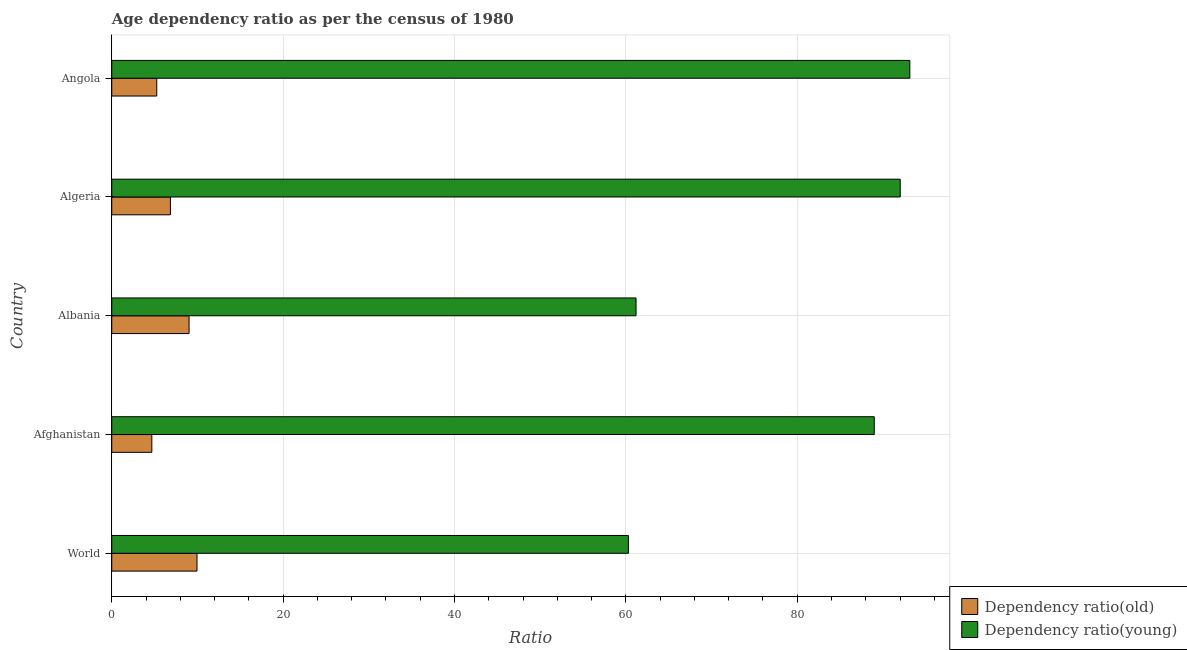How many different coloured bars are there?
Your response must be concise. 2. How many groups of bars are there?
Make the answer very short. 5. Are the number of bars per tick equal to the number of legend labels?
Your answer should be very brief. Yes. How many bars are there on the 1st tick from the top?
Provide a succinct answer. 2. What is the label of the 4th group of bars from the top?
Offer a very short reply. Afghanistan. In how many cases, is the number of bars for a given country not equal to the number of legend labels?
Offer a terse response. 0. What is the age dependency ratio(old) in Afghanistan?
Your answer should be very brief. 4.68. Across all countries, what is the maximum age dependency ratio(young)?
Make the answer very short. 93.14. Across all countries, what is the minimum age dependency ratio(young)?
Make the answer very short. 60.3. In which country was the age dependency ratio(old) maximum?
Give a very brief answer. World. In which country was the age dependency ratio(old) minimum?
Offer a terse response. Afghanistan. What is the total age dependency ratio(old) in the graph?
Give a very brief answer. 35.75. What is the difference between the age dependency ratio(old) in Algeria and that in Angola?
Make the answer very short. 1.59. What is the difference between the age dependency ratio(old) in Angola and the age dependency ratio(young) in Albania?
Offer a very short reply. -55.93. What is the average age dependency ratio(young) per country?
Keep it short and to the point. 79.13. What is the difference between the age dependency ratio(old) and age dependency ratio(young) in Afghanistan?
Ensure brevity in your answer.  -84.31. What is the ratio of the age dependency ratio(young) in Albania to that in Angola?
Make the answer very short. 0.66. What is the difference between the highest and the second highest age dependency ratio(young)?
Provide a succinct answer. 1.12. What is the difference between the highest and the lowest age dependency ratio(young)?
Ensure brevity in your answer.  32.84. In how many countries, is the age dependency ratio(old) greater than the average age dependency ratio(old) taken over all countries?
Make the answer very short. 2. What does the 1st bar from the top in Afghanistan represents?
Ensure brevity in your answer.  Dependency ratio(young). What does the 1st bar from the bottom in World represents?
Keep it short and to the point. Dependency ratio(old). How many bars are there?
Offer a very short reply. 10. Are all the bars in the graph horizontal?
Offer a terse response. Yes. How many countries are there in the graph?
Your answer should be compact. 5. What is the difference between two consecutive major ticks on the X-axis?
Your answer should be very brief. 20. Are the values on the major ticks of X-axis written in scientific E-notation?
Offer a terse response. No. Does the graph contain grids?
Provide a succinct answer. Yes. Where does the legend appear in the graph?
Your answer should be compact. Bottom right. How many legend labels are there?
Provide a short and direct response. 2. What is the title of the graph?
Give a very brief answer. Age dependency ratio as per the census of 1980. Does "Drinking water services" appear as one of the legend labels in the graph?
Provide a short and direct response. No. What is the label or title of the X-axis?
Your response must be concise. Ratio. What is the label or title of the Y-axis?
Your answer should be compact. Country. What is the Ratio of Dependency ratio(old) in World?
Offer a terse response. 9.95. What is the Ratio in Dependency ratio(young) in World?
Give a very brief answer. 60.3. What is the Ratio in Dependency ratio(old) in Afghanistan?
Ensure brevity in your answer.  4.68. What is the Ratio of Dependency ratio(young) in Afghanistan?
Your answer should be compact. 88.99. What is the Ratio in Dependency ratio(old) in Albania?
Provide a succinct answer. 9.02. What is the Ratio in Dependency ratio(young) in Albania?
Give a very brief answer. 61.19. What is the Ratio in Dependency ratio(old) in Algeria?
Provide a short and direct response. 6.85. What is the Ratio of Dependency ratio(young) in Algeria?
Offer a very short reply. 92.02. What is the Ratio in Dependency ratio(old) in Angola?
Offer a very short reply. 5.25. What is the Ratio in Dependency ratio(young) in Angola?
Keep it short and to the point. 93.14. Across all countries, what is the maximum Ratio of Dependency ratio(old)?
Your answer should be very brief. 9.95. Across all countries, what is the maximum Ratio in Dependency ratio(young)?
Your answer should be very brief. 93.14. Across all countries, what is the minimum Ratio of Dependency ratio(old)?
Give a very brief answer. 4.68. Across all countries, what is the minimum Ratio of Dependency ratio(young)?
Offer a terse response. 60.3. What is the total Ratio in Dependency ratio(old) in the graph?
Your answer should be very brief. 35.75. What is the total Ratio of Dependency ratio(young) in the graph?
Your answer should be compact. 395.64. What is the difference between the Ratio in Dependency ratio(old) in World and that in Afghanistan?
Give a very brief answer. 5.27. What is the difference between the Ratio in Dependency ratio(young) in World and that in Afghanistan?
Your answer should be compact. -28.69. What is the difference between the Ratio in Dependency ratio(old) in World and that in Albania?
Provide a succinct answer. 0.93. What is the difference between the Ratio of Dependency ratio(young) in World and that in Albania?
Give a very brief answer. -0.89. What is the difference between the Ratio in Dependency ratio(old) in World and that in Algeria?
Your answer should be compact. 3.1. What is the difference between the Ratio of Dependency ratio(young) in World and that in Algeria?
Provide a succinct answer. -31.72. What is the difference between the Ratio in Dependency ratio(old) in World and that in Angola?
Give a very brief answer. 4.69. What is the difference between the Ratio of Dependency ratio(young) in World and that in Angola?
Keep it short and to the point. -32.84. What is the difference between the Ratio of Dependency ratio(old) in Afghanistan and that in Albania?
Provide a short and direct response. -4.35. What is the difference between the Ratio in Dependency ratio(young) in Afghanistan and that in Albania?
Provide a succinct answer. 27.8. What is the difference between the Ratio in Dependency ratio(old) in Afghanistan and that in Algeria?
Keep it short and to the point. -2.17. What is the difference between the Ratio in Dependency ratio(young) in Afghanistan and that in Algeria?
Offer a terse response. -3.03. What is the difference between the Ratio of Dependency ratio(old) in Afghanistan and that in Angola?
Provide a short and direct response. -0.58. What is the difference between the Ratio in Dependency ratio(young) in Afghanistan and that in Angola?
Your answer should be compact. -4.15. What is the difference between the Ratio of Dependency ratio(old) in Albania and that in Algeria?
Your answer should be very brief. 2.18. What is the difference between the Ratio of Dependency ratio(young) in Albania and that in Algeria?
Your answer should be compact. -30.83. What is the difference between the Ratio of Dependency ratio(old) in Albania and that in Angola?
Your answer should be compact. 3.77. What is the difference between the Ratio in Dependency ratio(young) in Albania and that in Angola?
Give a very brief answer. -31.95. What is the difference between the Ratio of Dependency ratio(old) in Algeria and that in Angola?
Provide a succinct answer. 1.59. What is the difference between the Ratio in Dependency ratio(young) in Algeria and that in Angola?
Offer a terse response. -1.12. What is the difference between the Ratio of Dependency ratio(old) in World and the Ratio of Dependency ratio(young) in Afghanistan?
Ensure brevity in your answer.  -79.04. What is the difference between the Ratio of Dependency ratio(old) in World and the Ratio of Dependency ratio(young) in Albania?
Your response must be concise. -51.24. What is the difference between the Ratio of Dependency ratio(old) in World and the Ratio of Dependency ratio(young) in Algeria?
Provide a short and direct response. -82.07. What is the difference between the Ratio in Dependency ratio(old) in World and the Ratio in Dependency ratio(young) in Angola?
Offer a very short reply. -83.19. What is the difference between the Ratio in Dependency ratio(old) in Afghanistan and the Ratio in Dependency ratio(young) in Albania?
Give a very brief answer. -56.51. What is the difference between the Ratio of Dependency ratio(old) in Afghanistan and the Ratio of Dependency ratio(young) in Algeria?
Provide a succinct answer. -87.34. What is the difference between the Ratio in Dependency ratio(old) in Afghanistan and the Ratio in Dependency ratio(young) in Angola?
Keep it short and to the point. -88.46. What is the difference between the Ratio of Dependency ratio(old) in Albania and the Ratio of Dependency ratio(young) in Algeria?
Your response must be concise. -83. What is the difference between the Ratio of Dependency ratio(old) in Albania and the Ratio of Dependency ratio(young) in Angola?
Your answer should be very brief. -84.12. What is the difference between the Ratio of Dependency ratio(old) in Algeria and the Ratio of Dependency ratio(young) in Angola?
Ensure brevity in your answer.  -86.29. What is the average Ratio of Dependency ratio(old) per country?
Your answer should be compact. 7.15. What is the average Ratio of Dependency ratio(young) per country?
Make the answer very short. 79.13. What is the difference between the Ratio in Dependency ratio(old) and Ratio in Dependency ratio(young) in World?
Your answer should be very brief. -50.35. What is the difference between the Ratio in Dependency ratio(old) and Ratio in Dependency ratio(young) in Afghanistan?
Make the answer very short. -84.31. What is the difference between the Ratio of Dependency ratio(old) and Ratio of Dependency ratio(young) in Albania?
Your answer should be compact. -52.17. What is the difference between the Ratio in Dependency ratio(old) and Ratio in Dependency ratio(young) in Algeria?
Your answer should be compact. -85.17. What is the difference between the Ratio of Dependency ratio(old) and Ratio of Dependency ratio(young) in Angola?
Offer a terse response. -87.89. What is the ratio of the Ratio in Dependency ratio(old) in World to that in Afghanistan?
Offer a very short reply. 2.13. What is the ratio of the Ratio in Dependency ratio(young) in World to that in Afghanistan?
Offer a terse response. 0.68. What is the ratio of the Ratio of Dependency ratio(old) in World to that in Albania?
Ensure brevity in your answer.  1.1. What is the ratio of the Ratio in Dependency ratio(young) in World to that in Albania?
Keep it short and to the point. 0.99. What is the ratio of the Ratio of Dependency ratio(old) in World to that in Algeria?
Provide a short and direct response. 1.45. What is the ratio of the Ratio in Dependency ratio(young) in World to that in Algeria?
Keep it short and to the point. 0.66. What is the ratio of the Ratio of Dependency ratio(old) in World to that in Angola?
Offer a terse response. 1.89. What is the ratio of the Ratio in Dependency ratio(young) in World to that in Angola?
Keep it short and to the point. 0.65. What is the ratio of the Ratio of Dependency ratio(old) in Afghanistan to that in Albania?
Provide a succinct answer. 0.52. What is the ratio of the Ratio of Dependency ratio(young) in Afghanistan to that in Albania?
Your answer should be compact. 1.45. What is the ratio of the Ratio of Dependency ratio(old) in Afghanistan to that in Algeria?
Provide a short and direct response. 0.68. What is the ratio of the Ratio of Dependency ratio(young) in Afghanistan to that in Algeria?
Offer a very short reply. 0.97. What is the ratio of the Ratio of Dependency ratio(old) in Afghanistan to that in Angola?
Your response must be concise. 0.89. What is the ratio of the Ratio of Dependency ratio(young) in Afghanistan to that in Angola?
Give a very brief answer. 0.96. What is the ratio of the Ratio of Dependency ratio(old) in Albania to that in Algeria?
Offer a very short reply. 1.32. What is the ratio of the Ratio of Dependency ratio(young) in Albania to that in Algeria?
Give a very brief answer. 0.67. What is the ratio of the Ratio in Dependency ratio(old) in Albania to that in Angola?
Offer a very short reply. 1.72. What is the ratio of the Ratio in Dependency ratio(young) in Albania to that in Angola?
Make the answer very short. 0.66. What is the ratio of the Ratio of Dependency ratio(old) in Algeria to that in Angola?
Your answer should be compact. 1.3. What is the difference between the highest and the second highest Ratio in Dependency ratio(old)?
Offer a terse response. 0.93. What is the difference between the highest and the second highest Ratio in Dependency ratio(young)?
Give a very brief answer. 1.12. What is the difference between the highest and the lowest Ratio in Dependency ratio(old)?
Provide a short and direct response. 5.27. What is the difference between the highest and the lowest Ratio in Dependency ratio(young)?
Your answer should be compact. 32.84. 